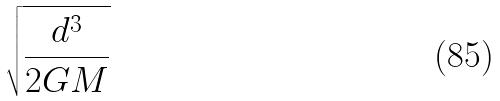Convert formula to latex. <formula><loc_0><loc_0><loc_500><loc_500>\sqrt { \frac { d ^ { 3 } } { 2 G M } }</formula> 